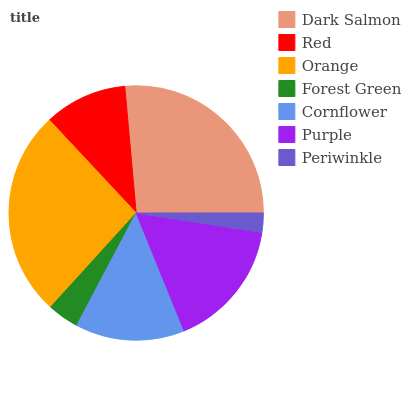Is Periwinkle the minimum?
Answer yes or no. Yes. Is Dark Salmon the maximum?
Answer yes or no. Yes. Is Red the minimum?
Answer yes or no. No. Is Red the maximum?
Answer yes or no. No. Is Dark Salmon greater than Red?
Answer yes or no. Yes. Is Red less than Dark Salmon?
Answer yes or no. Yes. Is Red greater than Dark Salmon?
Answer yes or no. No. Is Dark Salmon less than Red?
Answer yes or no. No. Is Cornflower the high median?
Answer yes or no. Yes. Is Cornflower the low median?
Answer yes or no. Yes. Is Orange the high median?
Answer yes or no. No. Is Orange the low median?
Answer yes or no. No. 